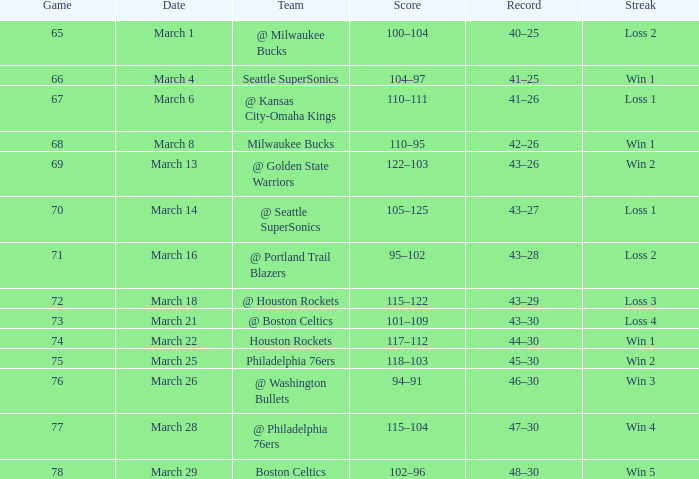What is the lowest game, when the date is the 21st of march? 73.0. 